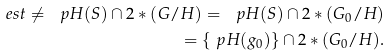<formula> <loc_0><loc_0><loc_500><loc_500>\ e s t \ne \ p H ( S ) \cap 2 \ast ( G / H ) = \ p H ( S ) \cap 2 \ast ( G _ { 0 } / H ) \\ = \{ \ p H ( g _ { 0 } ) \} \cap 2 \ast ( G _ { 0 } / H ) .</formula> 